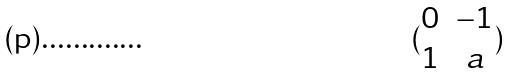<formula> <loc_0><loc_0><loc_500><loc_500>( \begin{matrix} 0 & - 1 \\ 1 & a \\ \end{matrix} )</formula> 